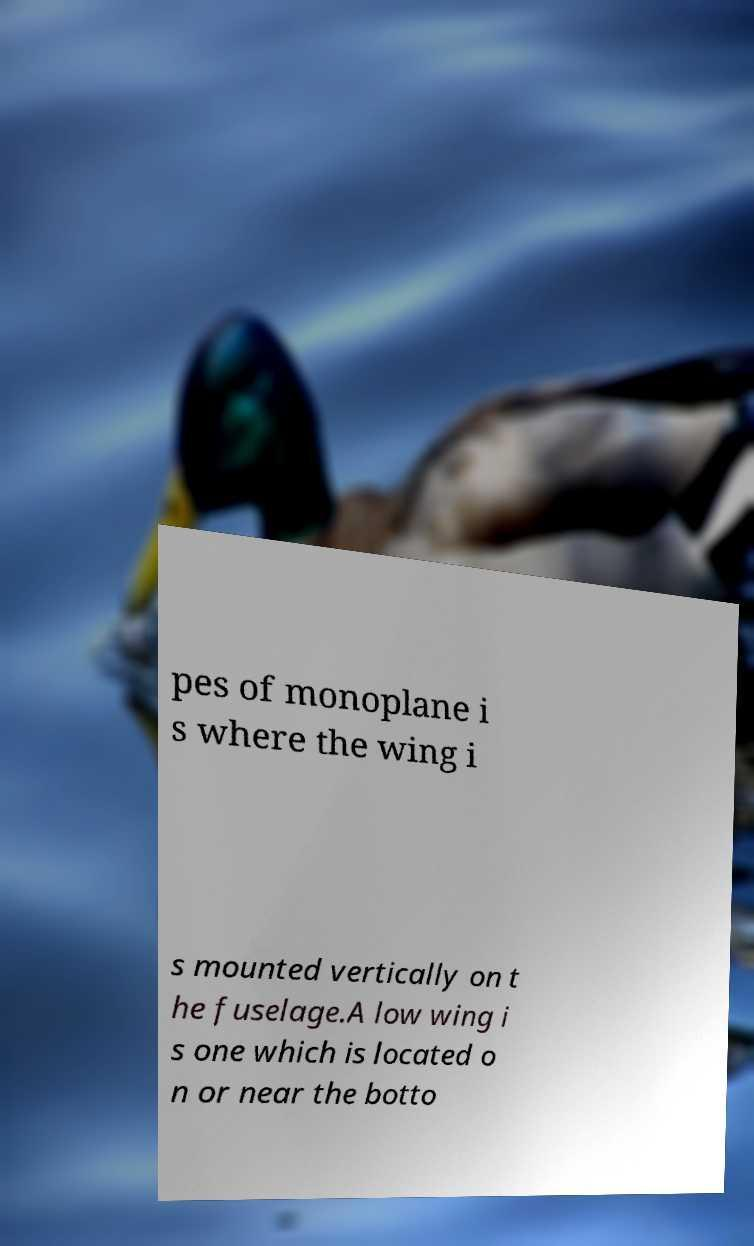Could you extract and type out the text from this image? pes of monoplane i s where the wing i s mounted vertically on t he fuselage.A low wing i s one which is located o n or near the botto 